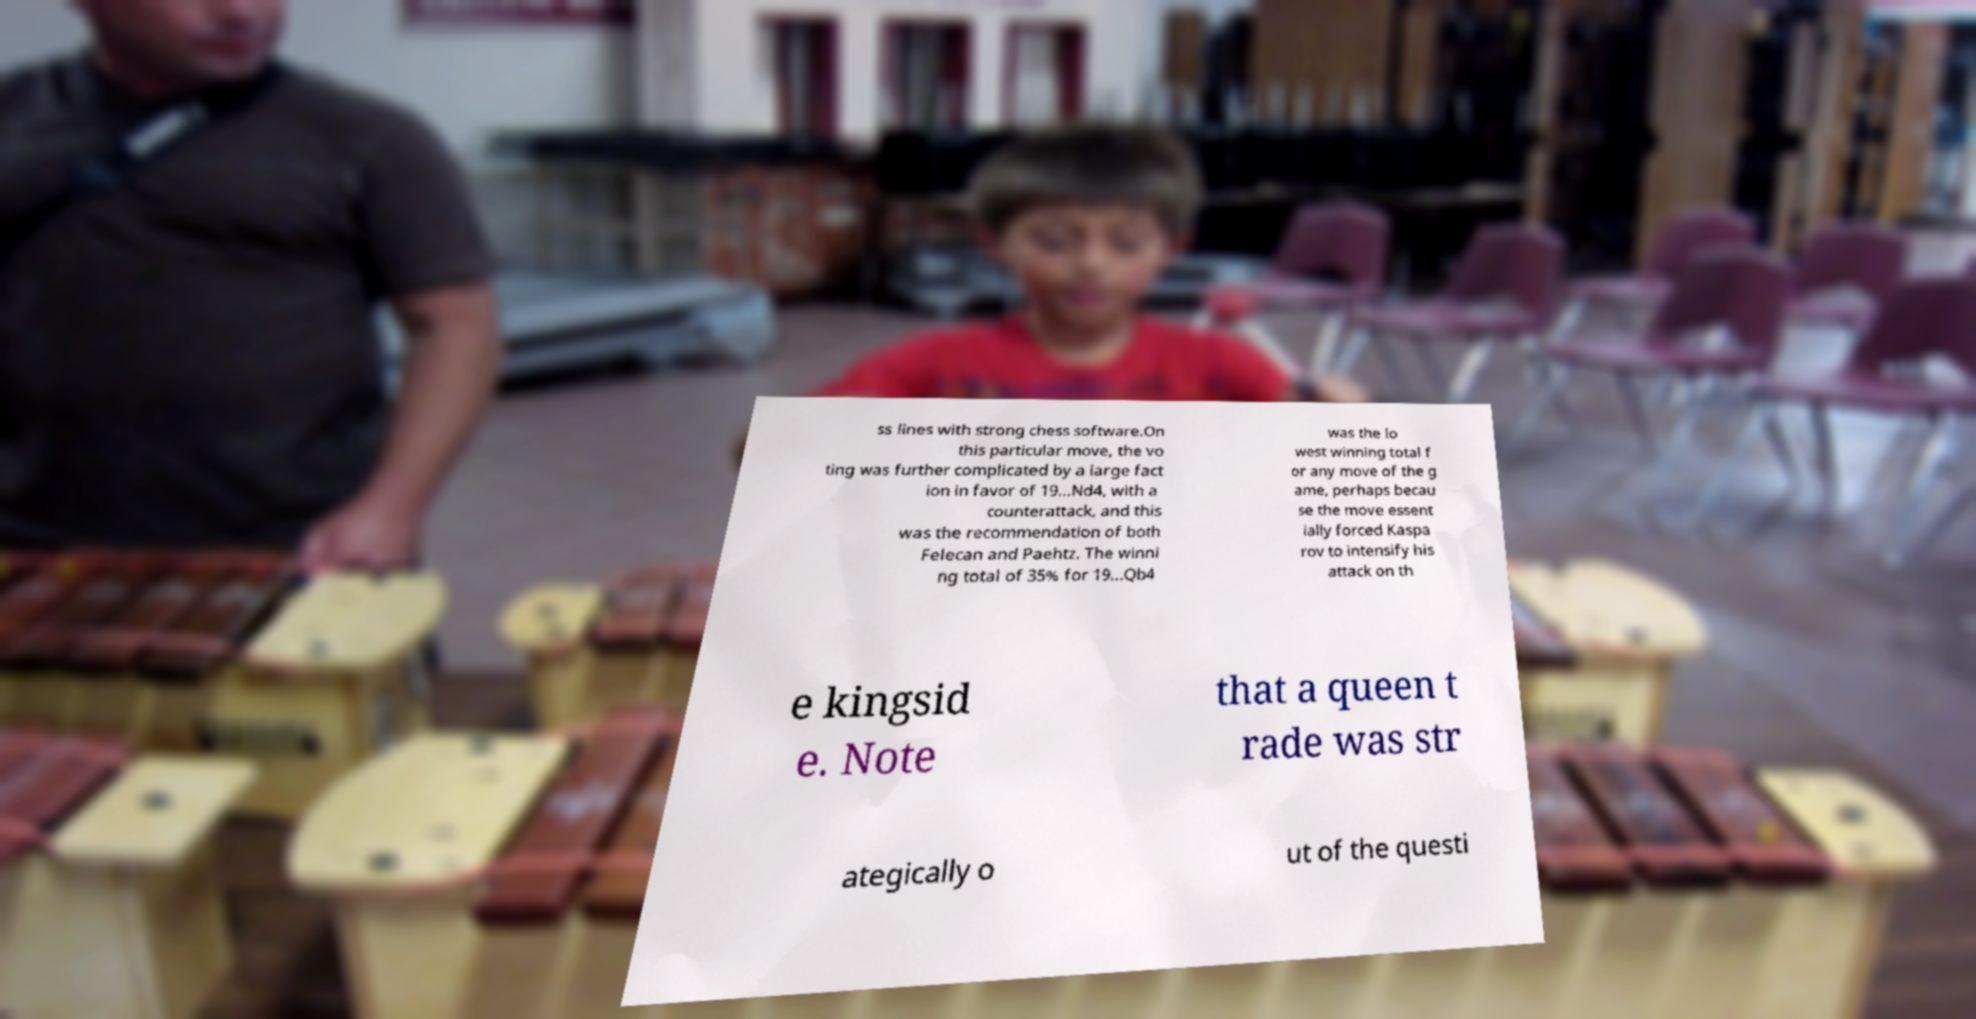I need the written content from this picture converted into text. Can you do that? ss lines with strong chess software.On this particular move, the vo ting was further complicated by a large fact ion in favor of 19...Nd4, with a counterattack, and this was the recommendation of both Felecan and Paehtz. The winni ng total of 35% for 19...Qb4 was the lo west winning total f or any move of the g ame, perhaps becau se the move essent ially forced Kaspa rov to intensify his attack on th e kingsid e. Note that a queen t rade was str ategically o ut of the questi 